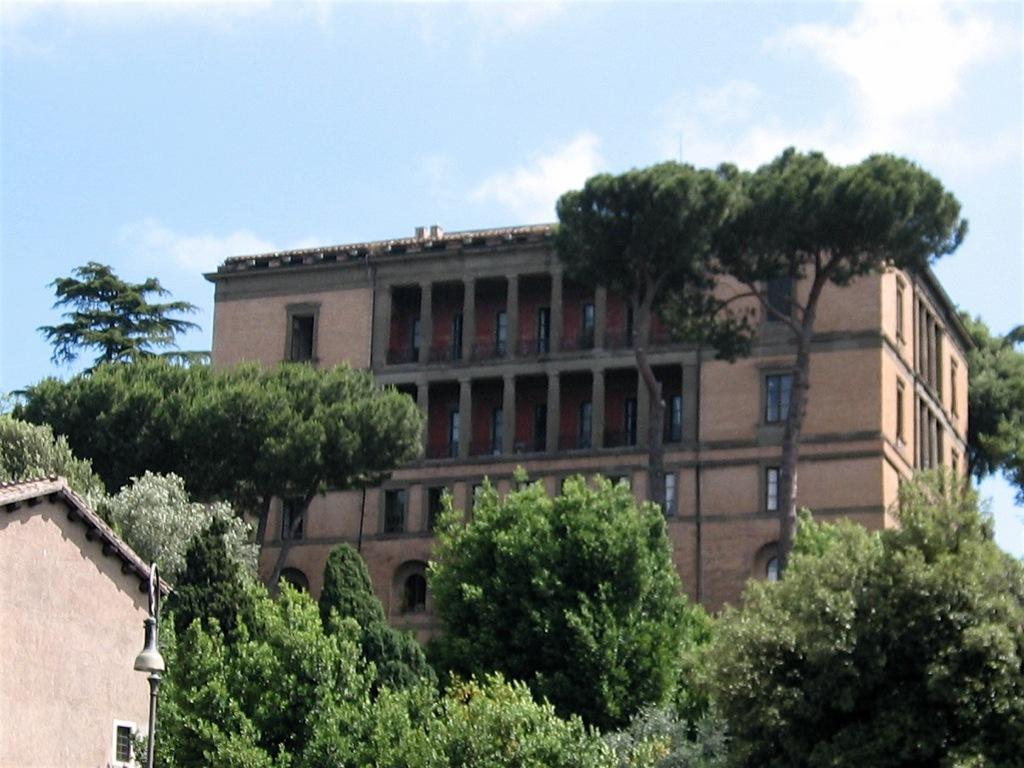Please provide a concise description of this image. In this image I can see many trees. To the left I can see the house with light. In the background I can see the building with windows, clouds and the sky. 